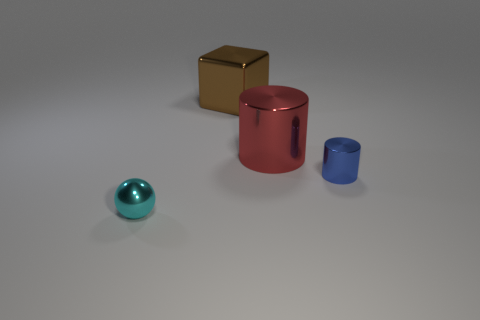If these objects were part of a set, what might be their function? If these objects were part of a set, they could represent a minimalist design concept for home decor or be used for educational purposes to teach shapes and colors. 